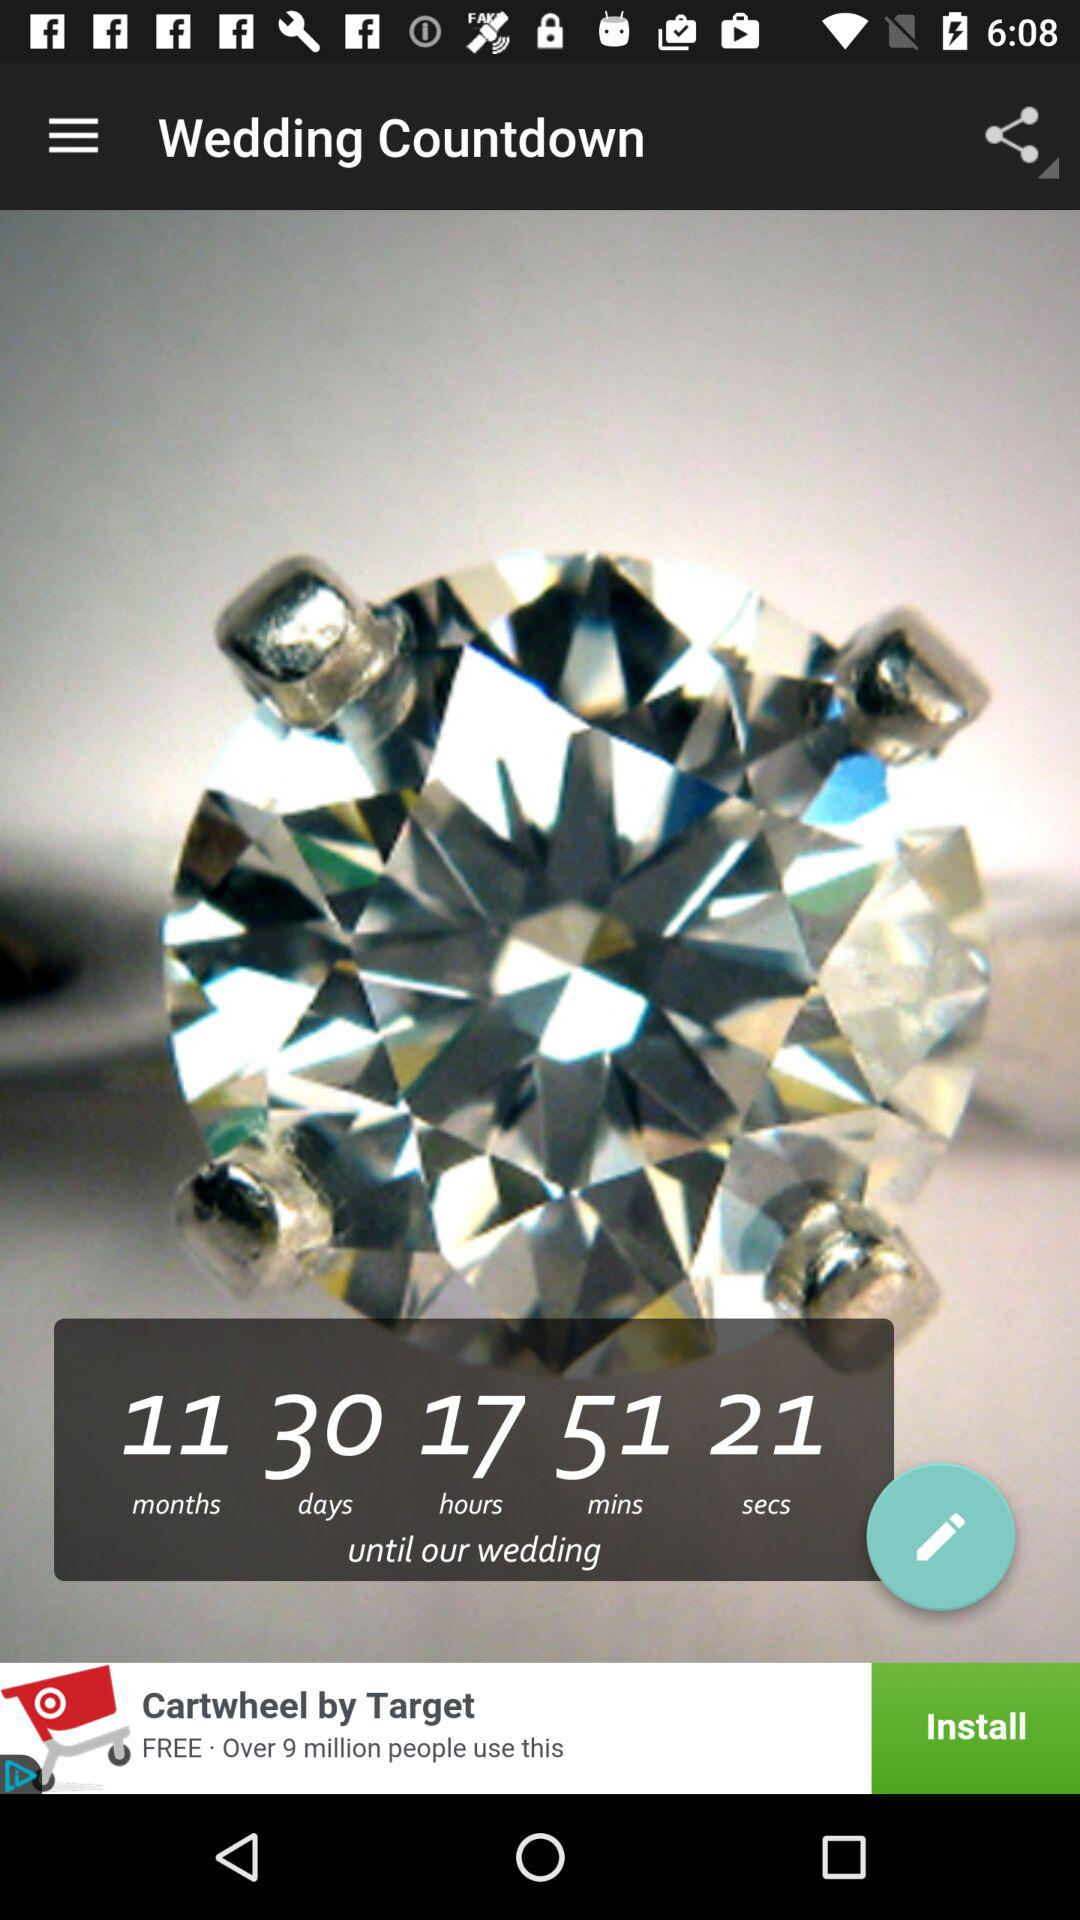How many days are left until the wedding? The number of days left until the wedding is 30. 